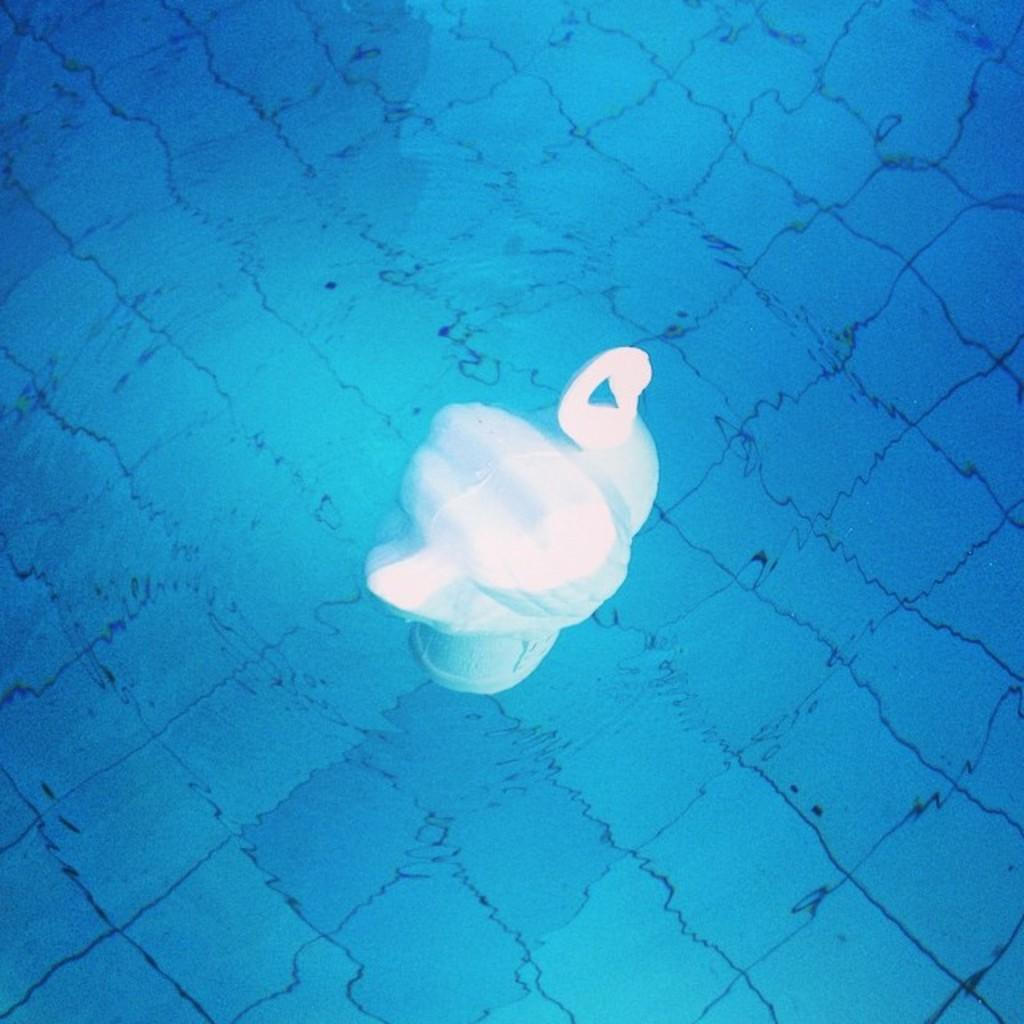What animal is present in the image? There is a swan in the image. Where is the swan located? The swan is depicted in water. What type of government is depicted in the image? There is no government depicted in the image; it features a swan in water. What material is the swan made of in the image? The swan is not a physical object in the image; it is a depiction of a living creature in water. 